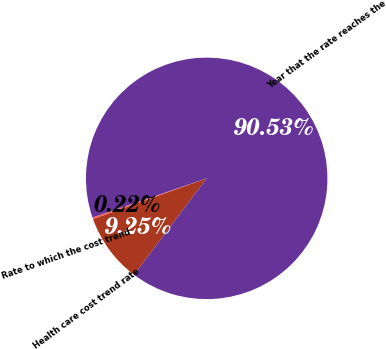Convert chart to OTSL. <chart><loc_0><loc_0><loc_500><loc_500><pie_chart><fcel>Health care cost trend rate<fcel>Rate to which the cost trend<fcel>Year that the rate reaches the<nl><fcel>9.25%<fcel>0.22%<fcel>90.52%<nl></chart> 